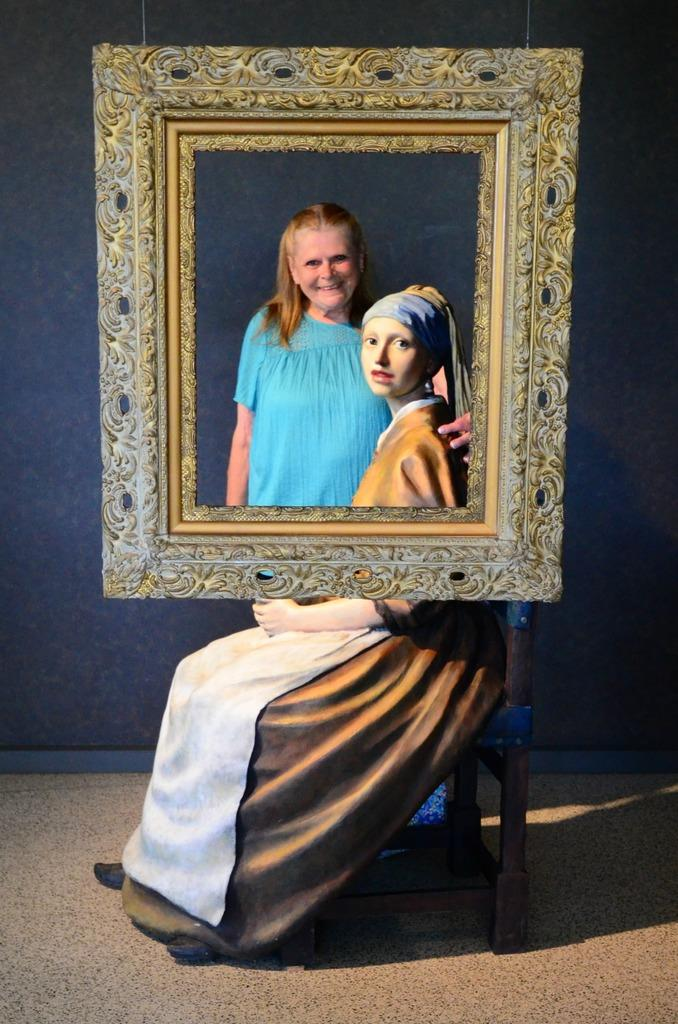How many people are in the image? There are people in the image, but the exact number is not specified. What is one person doing in the image? One person is sitting on a chair in the image. What can be seen surrounding the people in the image? There is a frame and a wall in the background of the image, and a floor at the bottom of the image. Can you see a boat in the image? No, there is no boat present in the image. What type of pickle is being used as a prop in the image? There is no pickle present in the image. 